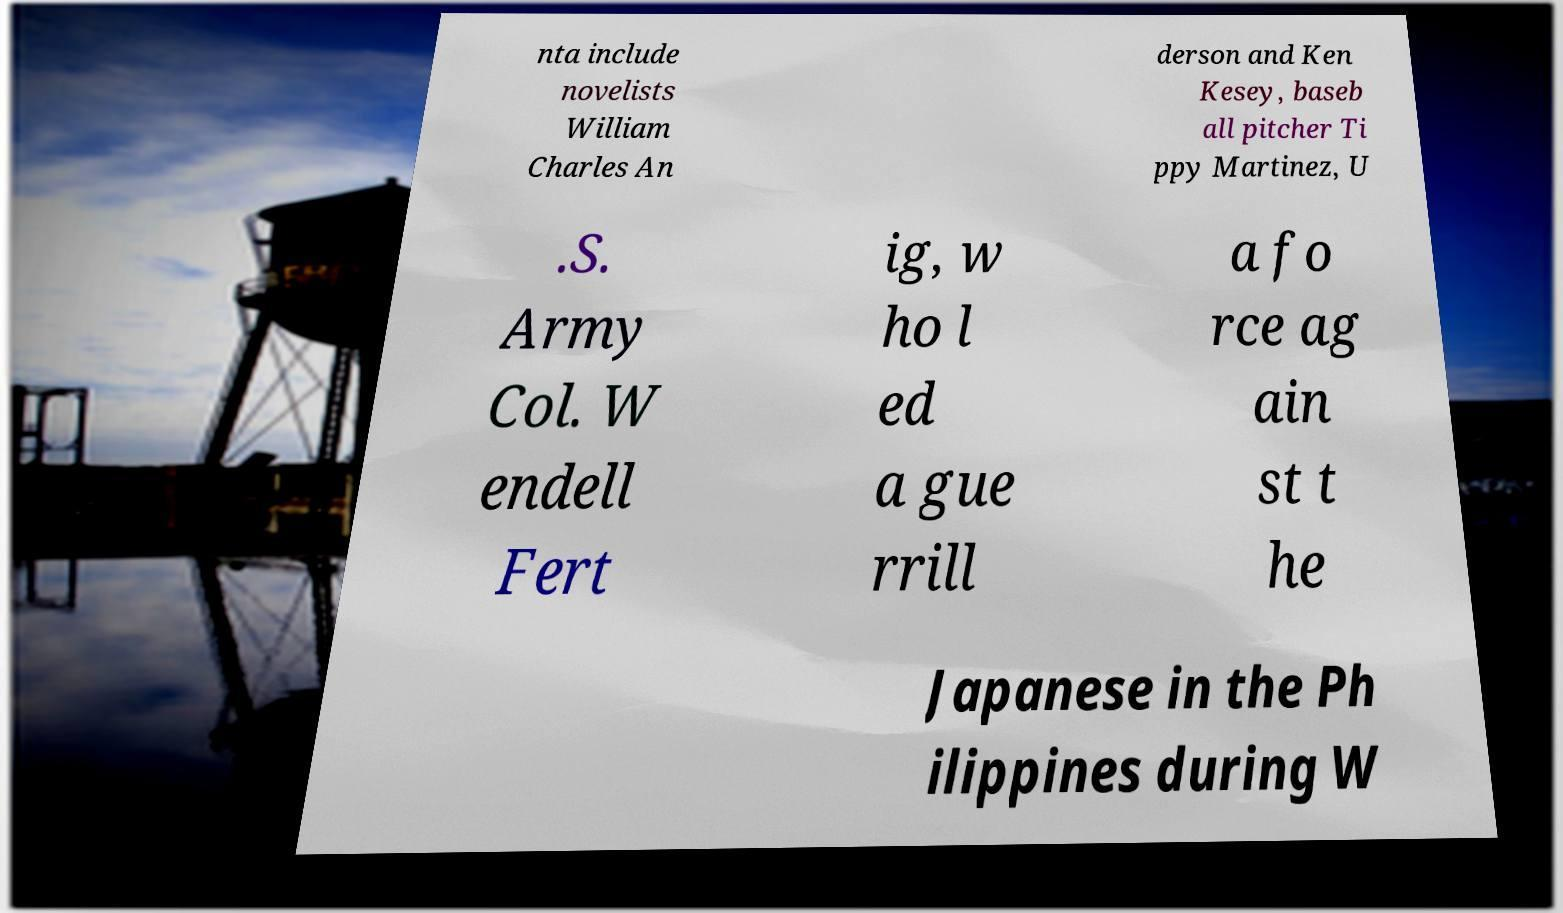Can you accurately transcribe the text from the provided image for me? nta include novelists William Charles An derson and Ken Kesey, baseb all pitcher Ti ppy Martinez, U .S. Army Col. W endell Fert ig, w ho l ed a gue rrill a fo rce ag ain st t he Japanese in the Ph ilippines during W 